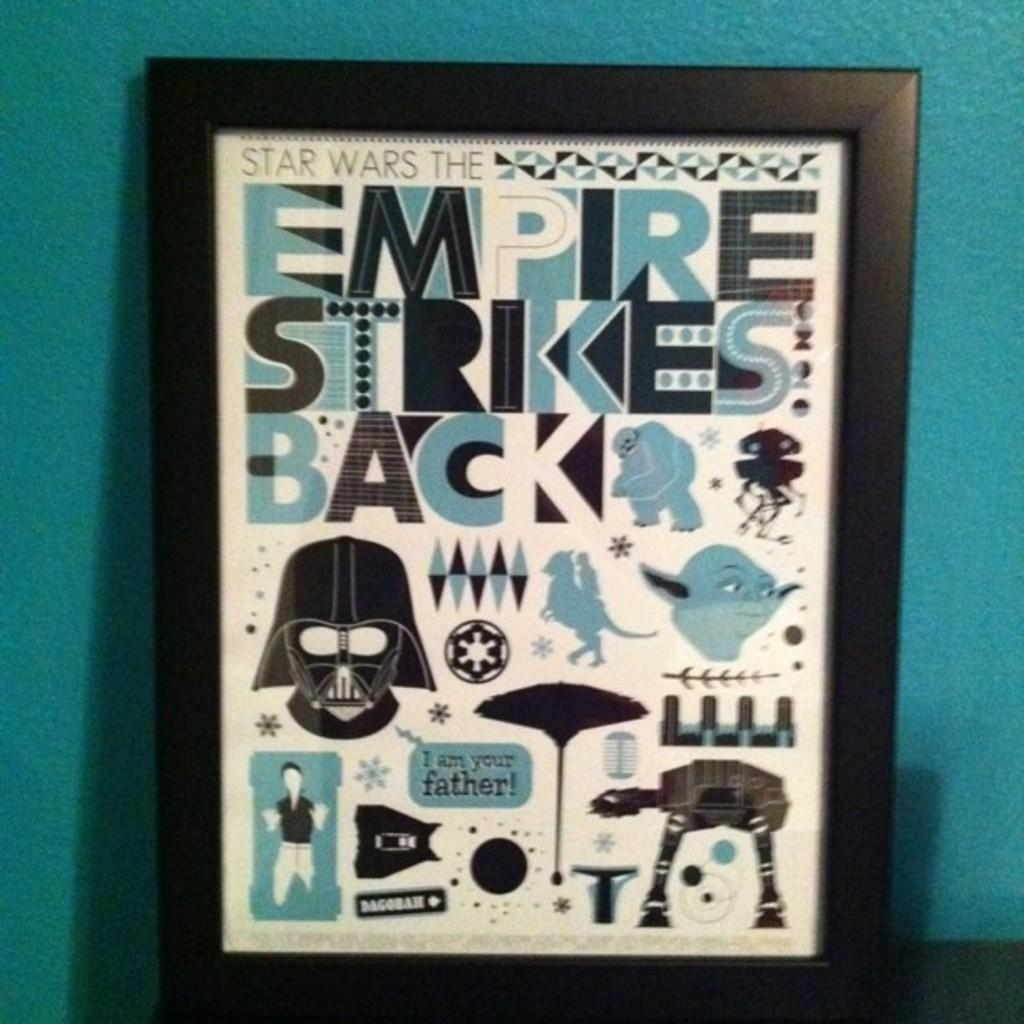<image>
Provide a brief description of the given image. Empire strikes back sign inside a picture frame. 